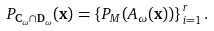Convert formula to latex. <formula><loc_0><loc_0><loc_500><loc_500>P _ { \mathbf C _ { \omega } \cap \mathbf D _ { \omega } } ( \mathbf x ) = \left \{ P _ { M } ( A _ { \omega } ( \mathbf x ) ) \right \} _ { i = 1 } ^ { r } .</formula> 